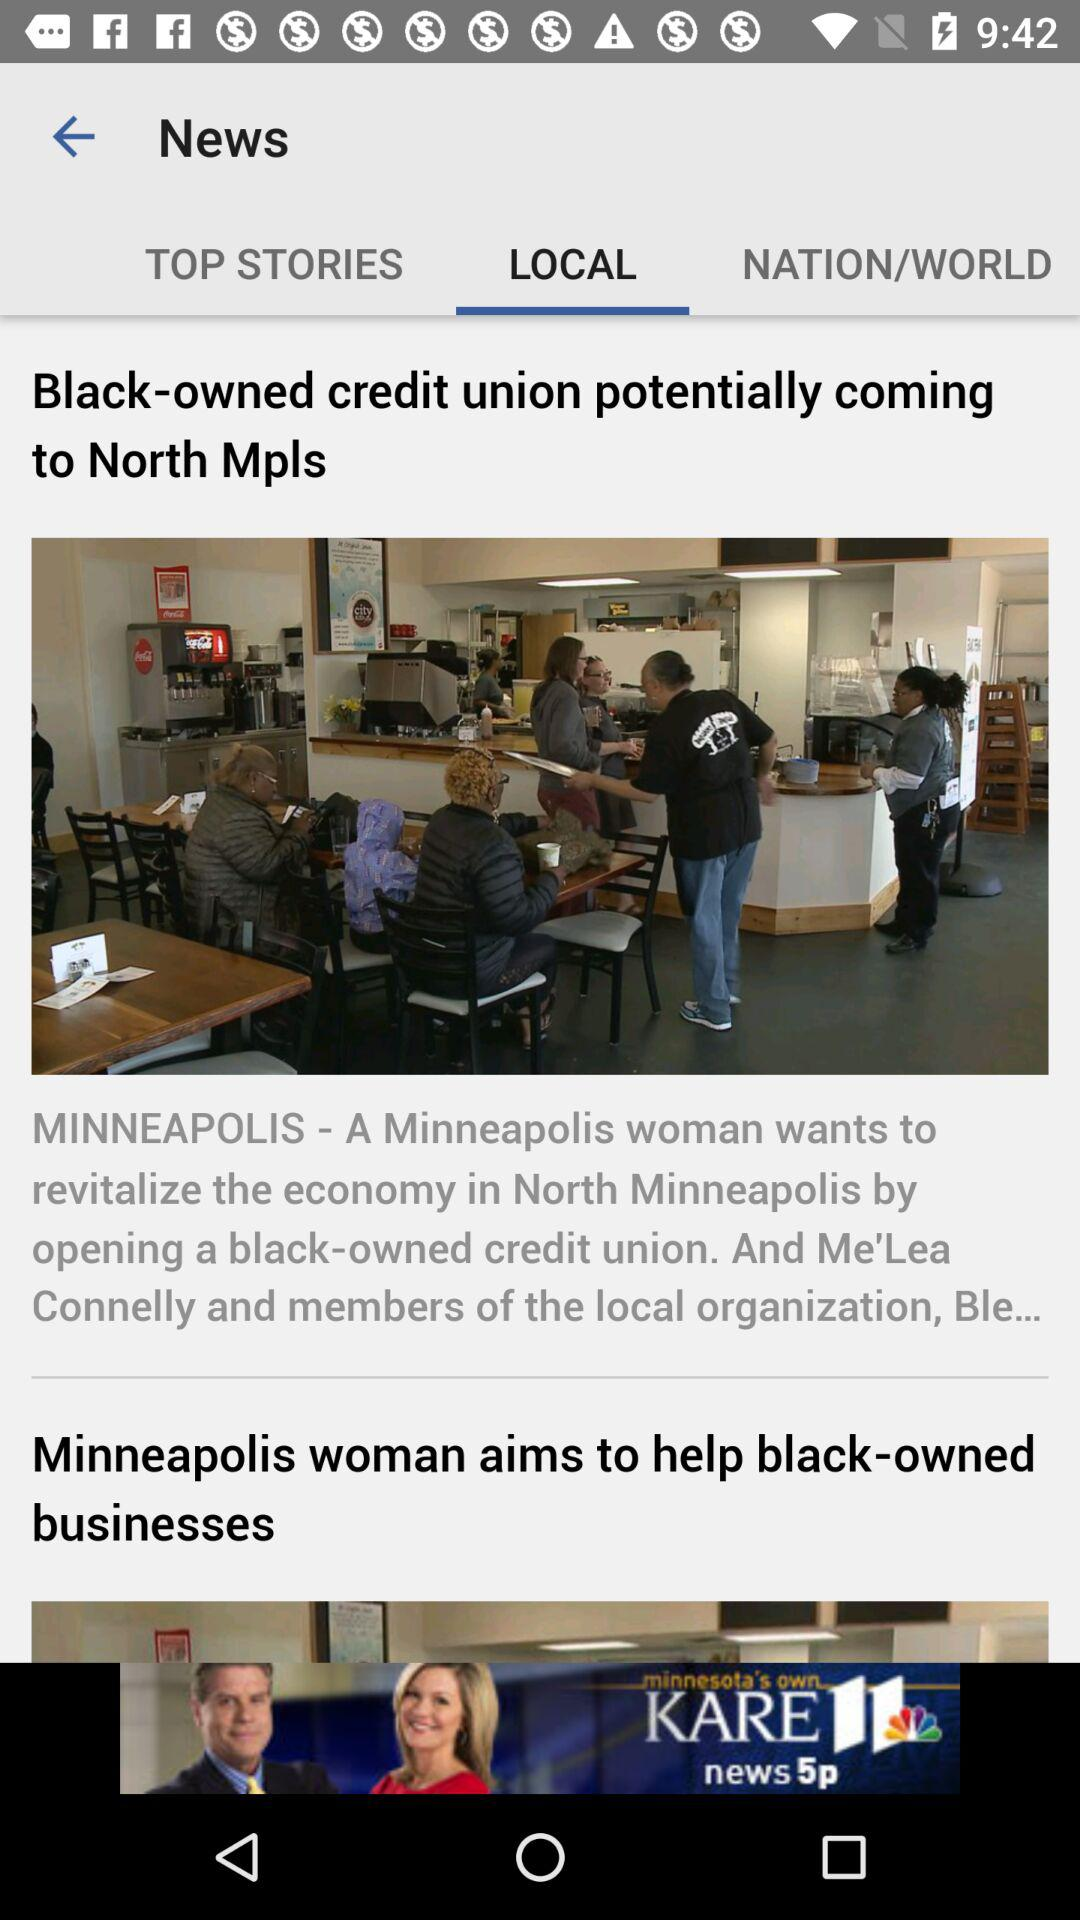How many articles are in "TOP STORIES"?
When the provided information is insufficient, respond with <no answer>. <no answer> 